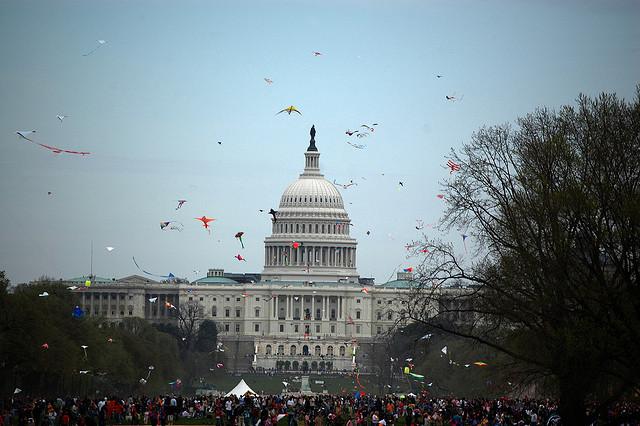Is there a way to tell time?
Answer briefly. No. Is there an event?
Write a very short answer. Yes. Is the tower from the medieval period?
Be succinct. No. What is at the top of the building?
Write a very short answer. Statue. What is in the sky?
Write a very short answer. Kites. What time of the year was this picture taken?
Answer briefly. Spring. Which US city is this?
Write a very short answer. Washington dc. 